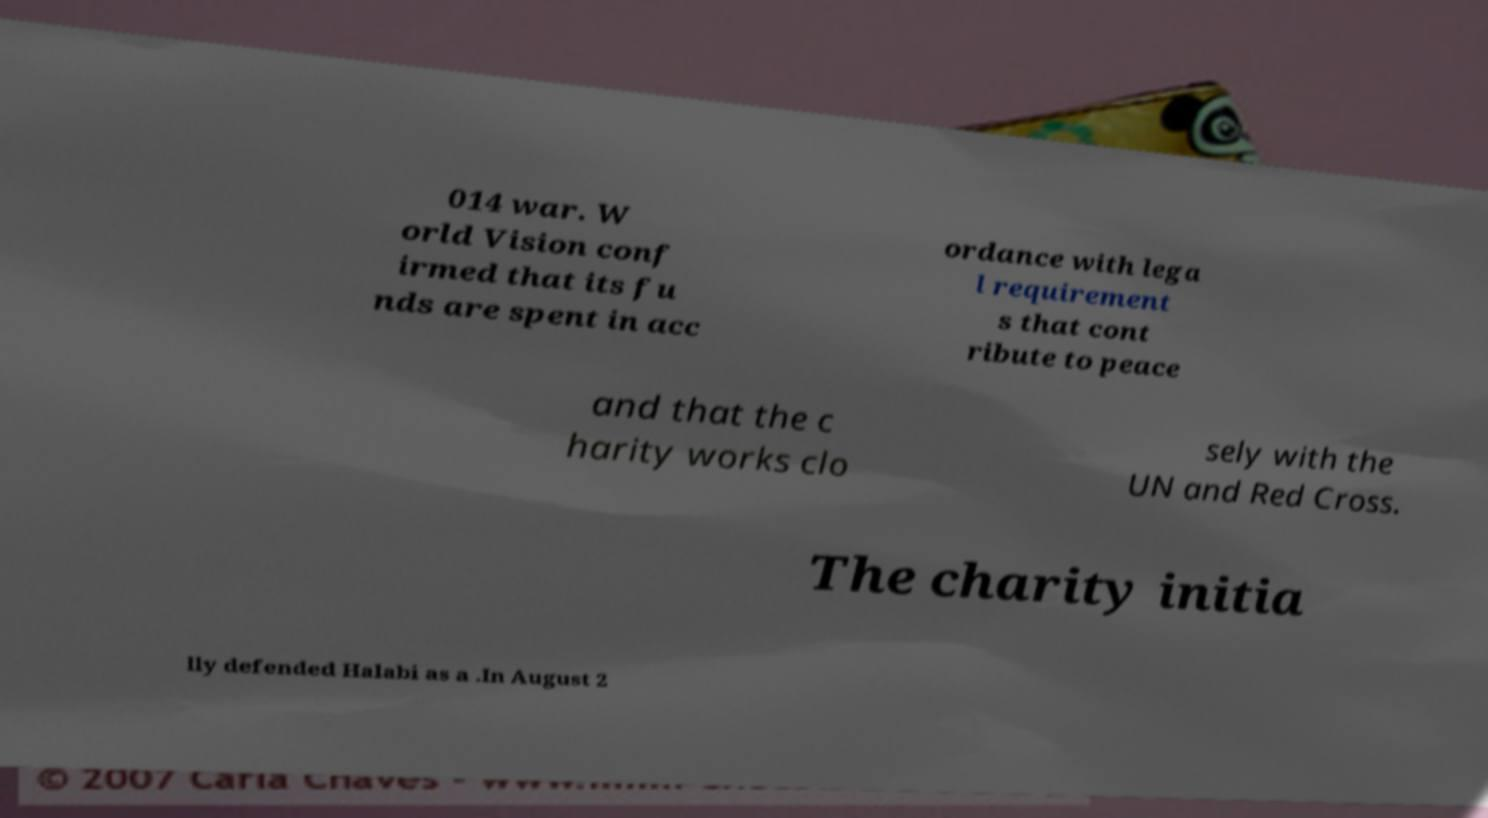There's text embedded in this image that I need extracted. Can you transcribe it verbatim? 014 war. W orld Vision conf irmed that its fu nds are spent in acc ordance with lega l requirement s that cont ribute to peace and that the c harity works clo sely with the UN and Red Cross. The charity initia lly defended Halabi as a .In August 2 